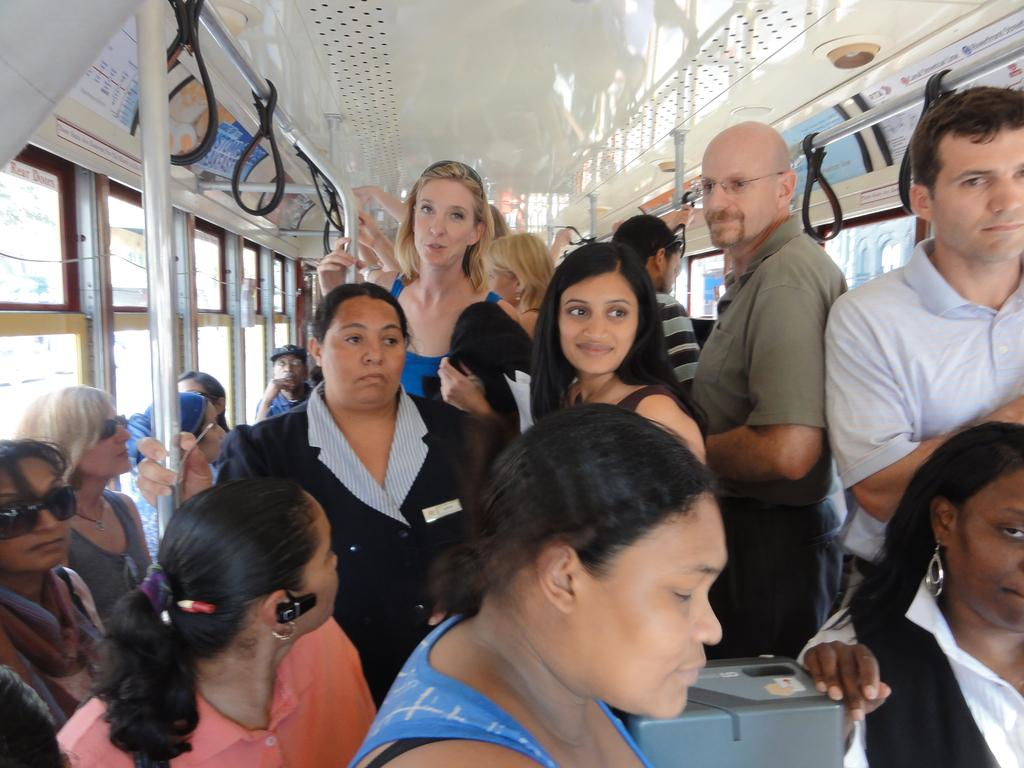What are the people in the vehicle doing? There are people sitting and standing in the vehicle. What feature can be seen on the vehicle that might be used for holding or support? Handles are visible in the image. What type of windows are present on the vehicle? Glass windows are present on both sides of the vehicle. What type of chalk is being used to write on the windows of the vehicle? There is no chalk present in the image, and no one is writing on the windows. Can you tell me how many baths are visible in the vehicle? There are no baths present in the vehicle; it is a mode of transportation with seats and windows. 